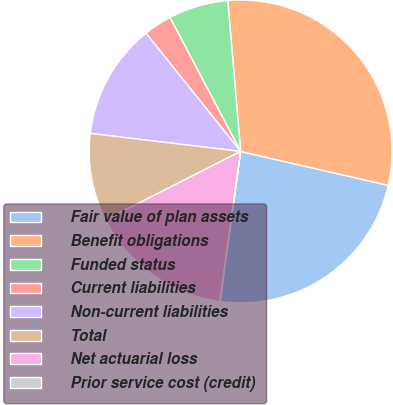<chart> <loc_0><loc_0><loc_500><loc_500><pie_chart><fcel>Fair value of plan assets<fcel>Benefit obligations<fcel>Funded status<fcel>Current liabilities<fcel>Non-current liabilities<fcel>Total<fcel>Net actuarial loss<fcel>Prior service cost (credit)<nl><fcel>23.58%<fcel>29.95%<fcel>6.37%<fcel>3.02%<fcel>12.35%<fcel>9.36%<fcel>15.35%<fcel>0.02%<nl></chart> 